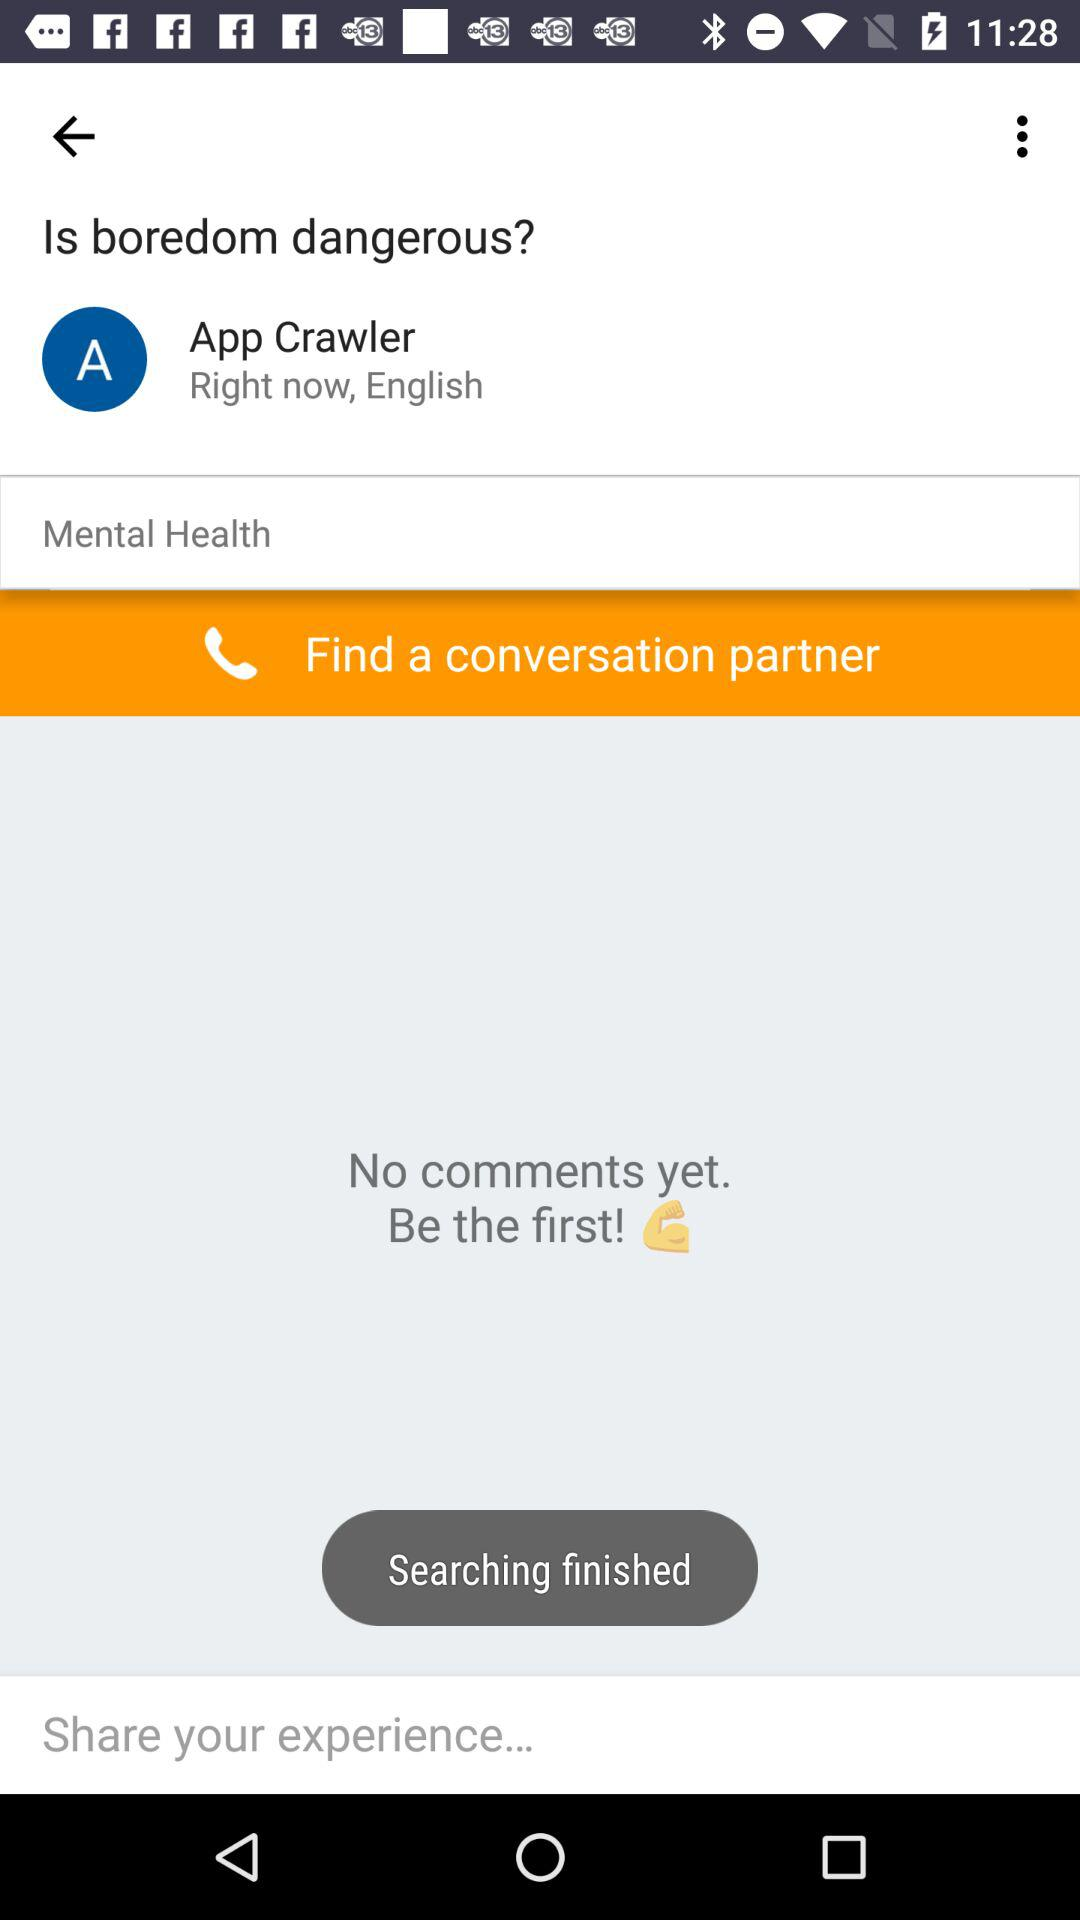What is the username? The user name is "App Crawler". 